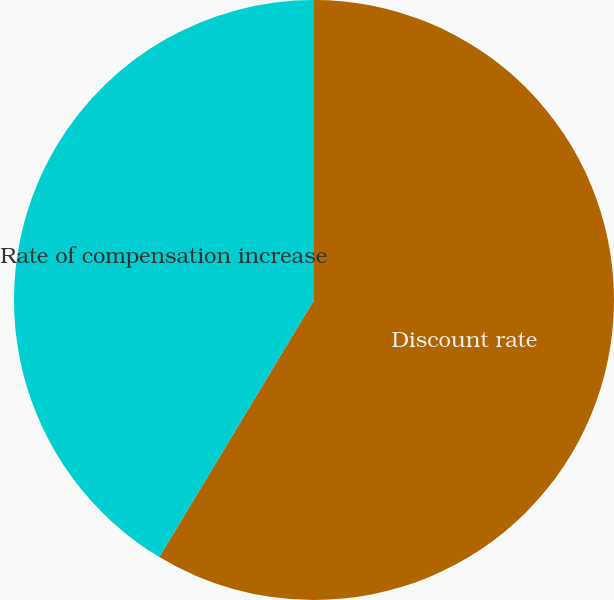Convert chart to OTSL. <chart><loc_0><loc_0><loc_500><loc_500><pie_chart><fcel>Discount rate<fcel>Rate of compensation increase<nl><fcel>58.62%<fcel>41.38%<nl></chart> 